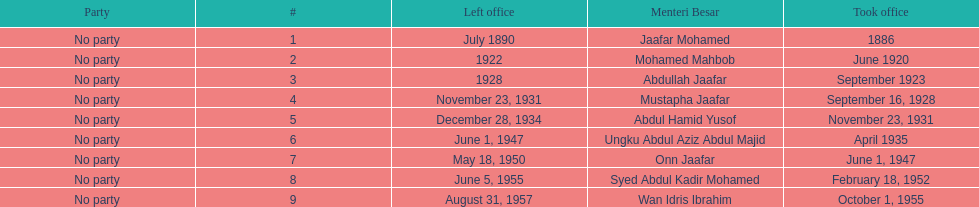Other than abullah jaafar, name someone with the same last name. Mustapha Jaafar. 